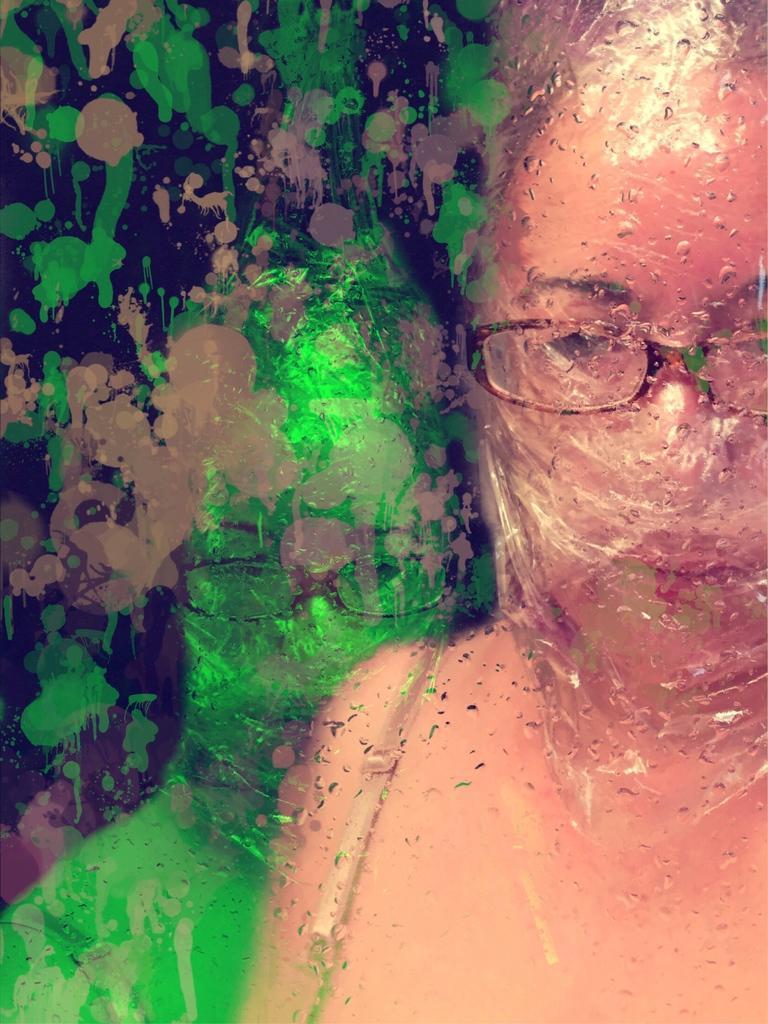Can you describe this image briefly? In this image we can see a woman wearing spectacles here. Here we can see the paint and reflection of her. 